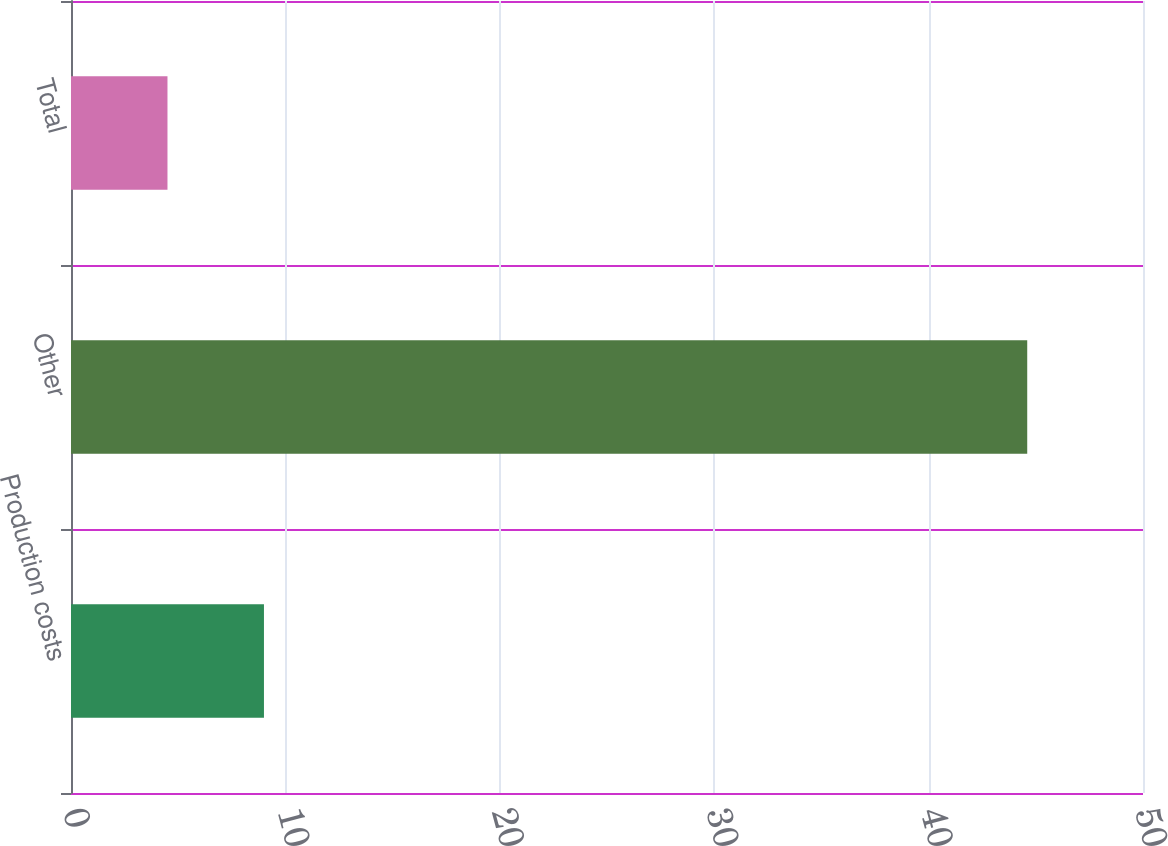Convert chart to OTSL. <chart><loc_0><loc_0><loc_500><loc_500><bar_chart><fcel>Production costs<fcel>Other<fcel>Total<nl><fcel>9<fcel>44.6<fcel>4.5<nl></chart> 